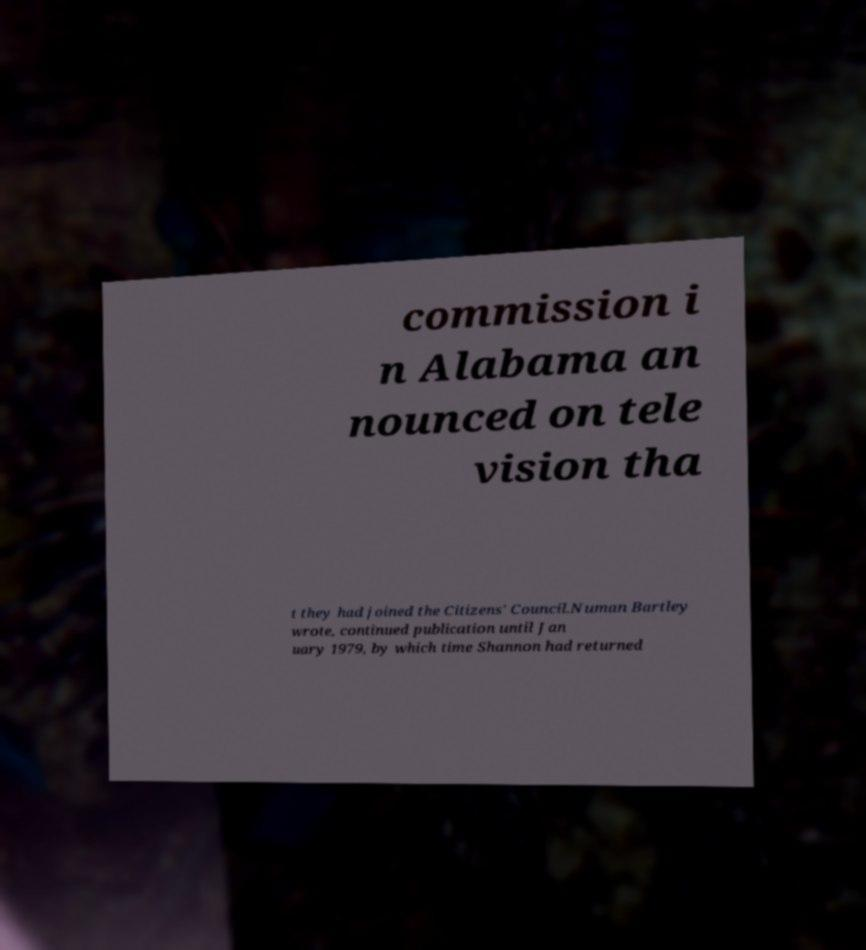For documentation purposes, I need the text within this image transcribed. Could you provide that? commission i n Alabama an nounced on tele vision tha t they had joined the Citizens' Council.Numan Bartley wrote, continued publication until Jan uary 1979, by which time Shannon had returned 